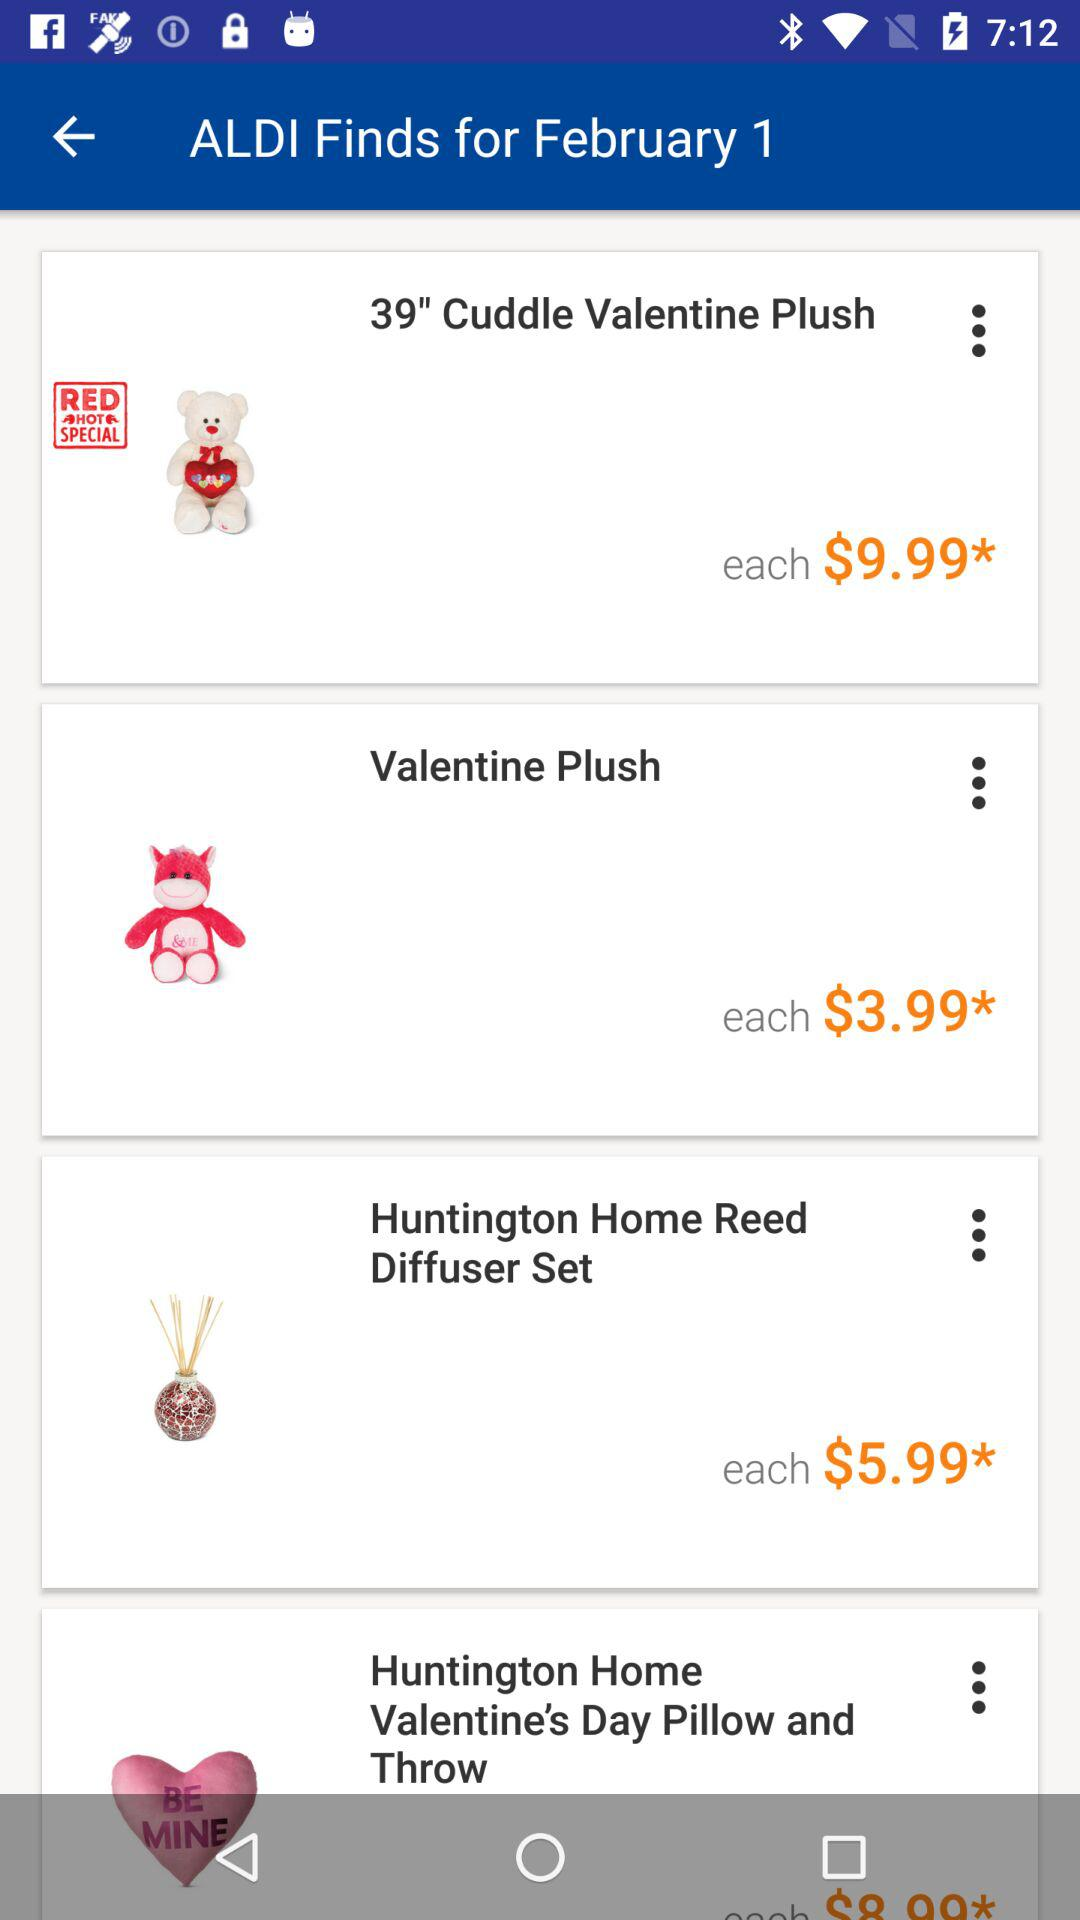What is the price of the "Valentine Plush"? The price of the "Valentine Plush" is $3.99. 